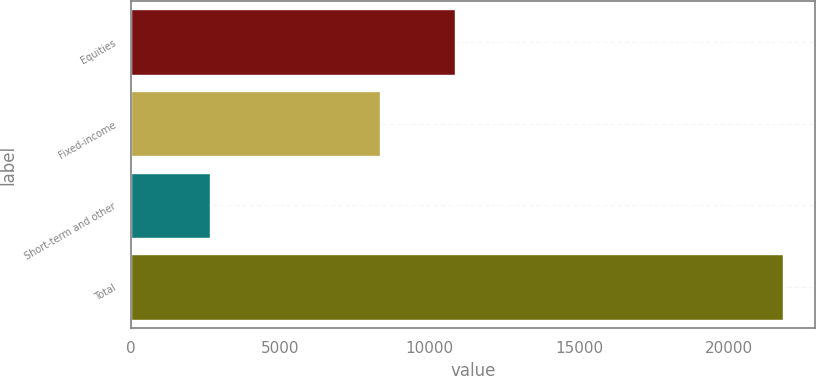Convert chart to OTSL. <chart><loc_0><loc_0><loc_500><loc_500><bar_chart><fcel>Equities<fcel>Fixed-income<fcel>Short-term and other<fcel>Total<nl><fcel>10849<fcel>8317<fcel>2641<fcel>21807<nl></chart> 